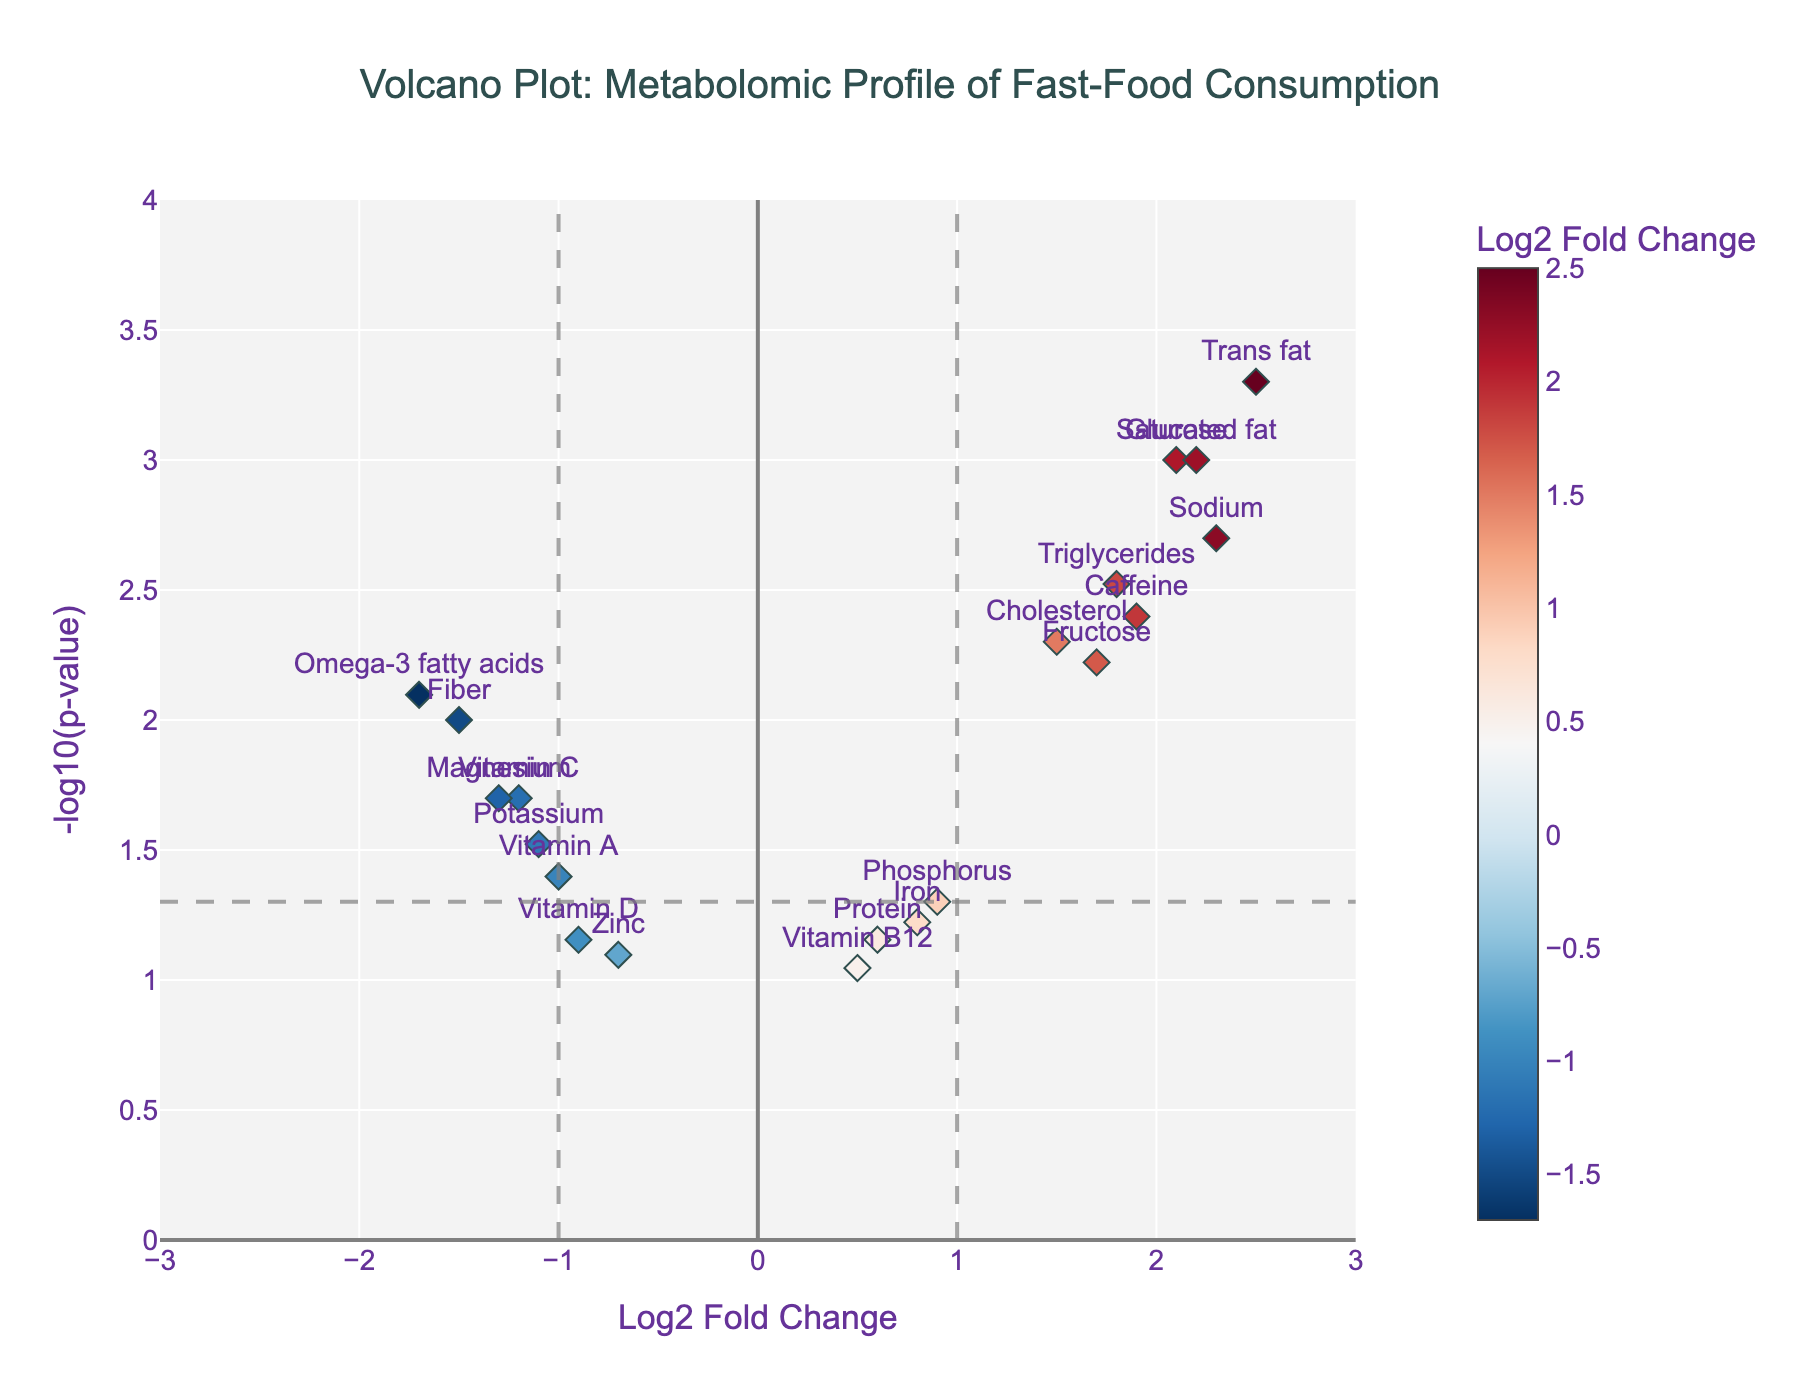What is the title of the volcano plot? The title is usually located at the top center of the plot. For this plot, the title is displayed in a larger font and says "Volcano Plot: Metabolomic Profile of Fast-Food Consumption".
Answer: Volcano Plot: Metabolomic Profile of Fast-Food Consumption What are the values of the x-axis and y-axis in the plot? The x-axis represents "Log2 Fold Change," which measures the change in metabolite levels, and the y-axis represents "-log10(p-value)," which indicates the statistical significance of the observations.
Answer: Log2 Fold Change and -log10(p-value) How many data points on the plot have a positive Log2 Fold Change greater than 2? To determine this, one must look at the x-axis values greater than 2 and count the corresponding markers. The data points with Log2 Fold Change greater than 2 are for "Sodium," "Saturated fat," and "Trans fat".
Answer: 3 Which metabolite shows the highest statistical significance, and what is its p-value? The highest statistical significance corresponds to the data point with the highest value on the y-axis. "Trans fat" shows the highest significance, corresponding to the lowest p-value. The hovertext indicates a p-value of 0.0005 for "Trans fat".
Answer: Trans fat, 0.0005 Which metabolite has the largest negative Log2 Fold Change, and what is its value? By looking at the x-axis for the most negative value, "Omega-3 fatty acids" has the largest negative Log2 Fold Change. The hovertext shows a Log2FoldChange of -1.7.
Answer: Omega-3 fatty acids, -1.7 Are there more metabolites with a positive or negative Log2 Fold Change? Count the number of markers on either side of the 0 on the x-axis. Positive values include Glucose, Triglycerides, Cholesterol, Sodium, Caffeine, Saturated fat, Trans fat, Fructose, Iron, Protein, Phosphorus, Vitamin B12. Negative values include Vitamin C, Fiber, Omega-3 fatty acids, Vitamin D, Potassium, Zinc, Magnesium, Vitamin A.
Answer: More with positive Log2 Fold Change Which metabolites have a Log2 Fold Change close to zero but are still not equal to zero? Look for points that are near zero but not exactly on the zero line. "Iron," and "Vitamin B12" have Log2 Fold Changes close to zero.
Answer: Iron, Vitamin B12 What is the Log2 Fold Change and -log10(p-value) for Fructose? By hovering over the "Fructose" point on the plot, the hovertext shows its Log2FoldChange is 1.7 and the -log10(p-value) can be calculated from p=0.006, which is approximately 2.22.
Answer: Log2FoldChange: 1.7, -log10(p): 2.22 How many metabolites have a p-value less than 0.01? Examine the y-axis for values greater than -log10(0.01), which is 2. The metabolites meeting this criterion are Glucose, Triglycerides, Sodium, Caffeine, Saturated fat, Trans fat, and Omega-3 fatty acids.
Answer: 7 Which metabolite shows both high statistical significance and a high Log2 Fold Change? A combination of high y-axis value (-log10(p-value)) and a high x-axis value (Log2 Fold Change) will help identify the metabolite. "Trans fat" has both high Log2 Fold Change (2.5) and high statistical significance (-log10(p) approximately 3.30).
Answer: Trans fat 